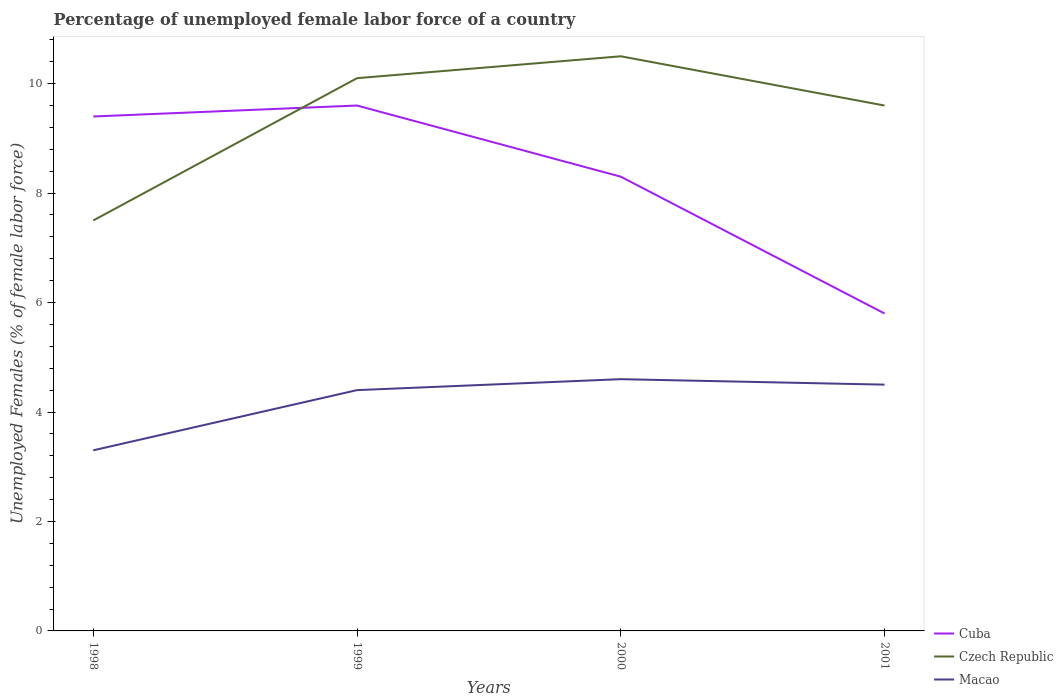Is the number of lines equal to the number of legend labels?
Offer a terse response. Yes. Across all years, what is the maximum percentage of unemployed female labor force in Cuba?
Make the answer very short. 5.8. In which year was the percentage of unemployed female labor force in Macao maximum?
Provide a short and direct response. 1998. What is the total percentage of unemployed female labor force in Czech Republic in the graph?
Your answer should be very brief. -0.4. What is the difference between the highest and the second highest percentage of unemployed female labor force in Cuba?
Your answer should be very brief. 3.8. Is the percentage of unemployed female labor force in Czech Republic strictly greater than the percentage of unemployed female labor force in Cuba over the years?
Ensure brevity in your answer.  No. How many lines are there?
Your response must be concise. 3. How many years are there in the graph?
Provide a short and direct response. 4. Are the values on the major ticks of Y-axis written in scientific E-notation?
Offer a very short reply. No. Does the graph contain grids?
Your answer should be very brief. No. How many legend labels are there?
Your answer should be compact. 3. What is the title of the graph?
Provide a short and direct response. Percentage of unemployed female labor force of a country. What is the label or title of the X-axis?
Your answer should be compact. Years. What is the label or title of the Y-axis?
Provide a short and direct response. Unemployed Females (% of female labor force). What is the Unemployed Females (% of female labor force) in Cuba in 1998?
Make the answer very short. 9.4. What is the Unemployed Females (% of female labor force) in Macao in 1998?
Your answer should be compact. 3.3. What is the Unemployed Females (% of female labor force) of Cuba in 1999?
Your response must be concise. 9.6. What is the Unemployed Females (% of female labor force) of Czech Republic in 1999?
Ensure brevity in your answer.  10.1. What is the Unemployed Females (% of female labor force) in Macao in 1999?
Make the answer very short. 4.4. What is the Unemployed Females (% of female labor force) of Cuba in 2000?
Offer a terse response. 8.3. What is the Unemployed Females (% of female labor force) of Czech Republic in 2000?
Provide a succinct answer. 10.5. What is the Unemployed Females (% of female labor force) in Macao in 2000?
Provide a succinct answer. 4.6. What is the Unemployed Females (% of female labor force) in Cuba in 2001?
Your answer should be compact. 5.8. What is the Unemployed Females (% of female labor force) of Czech Republic in 2001?
Make the answer very short. 9.6. Across all years, what is the maximum Unemployed Females (% of female labor force) in Cuba?
Keep it short and to the point. 9.6. Across all years, what is the maximum Unemployed Females (% of female labor force) in Czech Republic?
Make the answer very short. 10.5. Across all years, what is the maximum Unemployed Females (% of female labor force) of Macao?
Provide a short and direct response. 4.6. Across all years, what is the minimum Unemployed Females (% of female labor force) of Cuba?
Your answer should be very brief. 5.8. Across all years, what is the minimum Unemployed Females (% of female labor force) in Macao?
Make the answer very short. 3.3. What is the total Unemployed Females (% of female labor force) of Cuba in the graph?
Offer a terse response. 33.1. What is the total Unemployed Females (% of female labor force) of Czech Republic in the graph?
Keep it short and to the point. 37.7. What is the total Unemployed Females (% of female labor force) of Macao in the graph?
Give a very brief answer. 16.8. What is the difference between the Unemployed Females (% of female labor force) of Cuba in 1998 and that in 1999?
Make the answer very short. -0.2. What is the difference between the Unemployed Females (% of female labor force) in Cuba in 1998 and that in 2000?
Offer a very short reply. 1.1. What is the difference between the Unemployed Females (% of female labor force) of Czech Republic in 1998 and that in 2000?
Give a very brief answer. -3. What is the difference between the Unemployed Females (% of female labor force) of Czech Republic in 1998 and that in 2001?
Your response must be concise. -2.1. What is the difference between the Unemployed Females (% of female labor force) of Cuba in 1999 and that in 2000?
Make the answer very short. 1.3. What is the difference between the Unemployed Females (% of female labor force) in Czech Republic in 1999 and that in 2000?
Offer a terse response. -0.4. What is the difference between the Unemployed Females (% of female labor force) in Macao in 1999 and that in 2000?
Provide a succinct answer. -0.2. What is the difference between the Unemployed Females (% of female labor force) in Czech Republic in 1999 and that in 2001?
Make the answer very short. 0.5. What is the difference between the Unemployed Females (% of female labor force) of Cuba in 1998 and the Unemployed Females (% of female labor force) of Macao in 1999?
Make the answer very short. 5. What is the difference between the Unemployed Females (% of female labor force) of Czech Republic in 1998 and the Unemployed Females (% of female labor force) of Macao in 1999?
Your answer should be compact. 3.1. What is the difference between the Unemployed Females (% of female labor force) of Cuba in 1998 and the Unemployed Females (% of female labor force) of Czech Republic in 2000?
Offer a very short reply. -1.1. What is the difference between the Unemployed Females (% of female labor force) of Czech Republic in 1998 and the Unemployed Females (% of female labor force) of Macao in 2000?
Offer a very short reply. 2.9. What is the difference between the Unemployed Females (% of female labor force) in Cuba in 1998 and the Unemployed Females (% of female labor force) in Czech Republic in 2001?
Your answer should be very brief. -0.2. What is the difference between the Unemployed Females (% of female labor force) of Czech Republic in 1998 and the Unemployed Females (% of female labor force) of Macao in 2001?
Ensure brevity in your answer.  3. What is the difference between the Unemployed Females (% of female labor force) of Czech Republic in 1999 and the Unemployed Females (% of female labor force) of Macao in 2000?
Provide a short and direct response. 5.5. What is the difference between the Unemployed Females (% of female labor force) of Cuba in 1999 and the Unemployed Females (% of female labor force) of Macao in 2001?
Offer a very short reply. 5.1. What is the difference between the Unemployed Females (% of female labor force) in Czech Republic in 1999 and the Unemployed Females (% of female labor force) in Macao in 2001?
Offer a terse response. 5.6. What is the difference between the Unemployed Females (% of female labor force) in Cuba in 2000 and the Unemployed Females (% of female labor force) in Czech Republic in 2001?
Ensure brevity in your answer.  -1.3. What is the average Unemployed Females (% of female labor force) of Cuba per year?
Keep it short and to the point. 8.28. What is the average Unemployed Females (% of female labor force) in Czech Republic per year?
Your answer should be compact. 9.43. What is the average Unemployed Females (% of female labor force) of Macao per year?
Provide a short and direct response. 4.2. In the year 1999, what is the difference between the Unemployed Females (% of female labor force) in Cuba and Unemployed Females (% of female labor force) in Czech Republic?
Keep it short and to the point. -0.5. In the year 1999, what is the difference between the Unemployed Females (% of female labor force) in Cuba and Unemployed Females (% of female labor force) in Macao?
Ensure brevity in your answer.  5.2. In the year 1999, what is the difference between the Unemployed Females (% of female labor force) of Czech Republic and Unemployed Females (% of female labor force) of Macao?
Your answer should be very brief. 5.7. In the year 2001, what is the difference between the Unemployed Females (% of female labor force) of Cuba and Unemployed Females (% of female labor force) of Macao?
Offer a terse response. 1.3. In the year 2001, what is the difference between the Unemployed Females (% of female labor force) of Czech Republic and Unemployed Females (% of female labor force) of Macao?
Your answer should be very brief. 5.1. What is the ratio of the Unemployed Females (% of female labor force) of Cuba in 1998 to that in 1999?
Ensure brevity in your answer.  0.98. What is the ratio of the Unemployed Females (% of female labor force) in Czech Republic in 1998 to that in 1999?
Give a very brief answer. 0.74. What is the ratio of the Unemployed Females (% of female labor force) of Macao in 1998 to that in 1999?
Ensure brevity in your answer.  0.75. What is the ratio of the Unemployed Females (% of female labor force) in Cuba in 1998 to that in 2000?
Your answer should be very brief. 1.13. What is the ratio of the Unemployed Females (% of female labor force) in Czech Republic in 1998 to that in 2000?
Your answer should be very brief. 0.71. What is the ratio of the Unemployed Females (% of female labor force) in Macao in 1998 to that in 2000?
Give a very brief answer. 0.72. What is the ratio of the Unemployed Females (% of female labor force) of Cuba in 1998 to that in 2001?
Ensure brevity in your answer.  1.62. What is the ratio of the Unemployed Females (% of female labor force) in Czech Republic in 1998 to that in 2001?
Ensure brevity in your answer.  0.78. What is the ratio of the Unemployed Females (% of female labor force) in Macao in 1998 to that in 2001?
Your answer should be very brief. 0.73. What is the ratio of the Unemployed Females (% of female labor force) of Cuba in 1999 to that in 2000?
Offer a very short reply. 1.16. What is the ratio of the Unemployed Females (% of female labor force) in Czech Republic in 1999 to that in 2000?
Provide a succinct answer. 0.96. What is the ratio of the Unemployed Females (% of female labor force) of Macao in 1999 to that in 2000?
Your answer should be compact. 0.96. What is the ratio of the Unemployed Females (% of female labor force) in Cuba in 1999 to that in 2001?
Keep it short and to the point. 1.66. What is the ratio of the Unemployed Females (% of female labor force) in Czech Republic in 1999 to that in 2001?
Ensure brevity in your answer.  1.05. What is the ratio of the Unemployed Females (% of female labor force) of Macao in 1999 to that in 2001?
Provide a short and direct response. 0.98. What is the ratio of the Unemployed Females (% of female labor force) in Cuba in 2000 to that in 2001?
Your response must be concise. 1.43. What is the ratio of the Unemployed Females (% of female labor force) of Czech Republic in 2000 to that in 2001?
Provide a short and direct response. 1.09. What is the ratio of the Unemployed Females (% of female labor force) of Macao in 2000 to that in 2001?
Offer a very short reply. 1.02. What is the difference between the highest and the second highest Unemployed Females (% of female labor force) of Cuba?
Ensure brevity in your answer.  0.2. What is the difference between the highest and the second highest Unemployed Females (% of female labor force) in Czech Republic?
Your answer should be very brief. 0.4. 